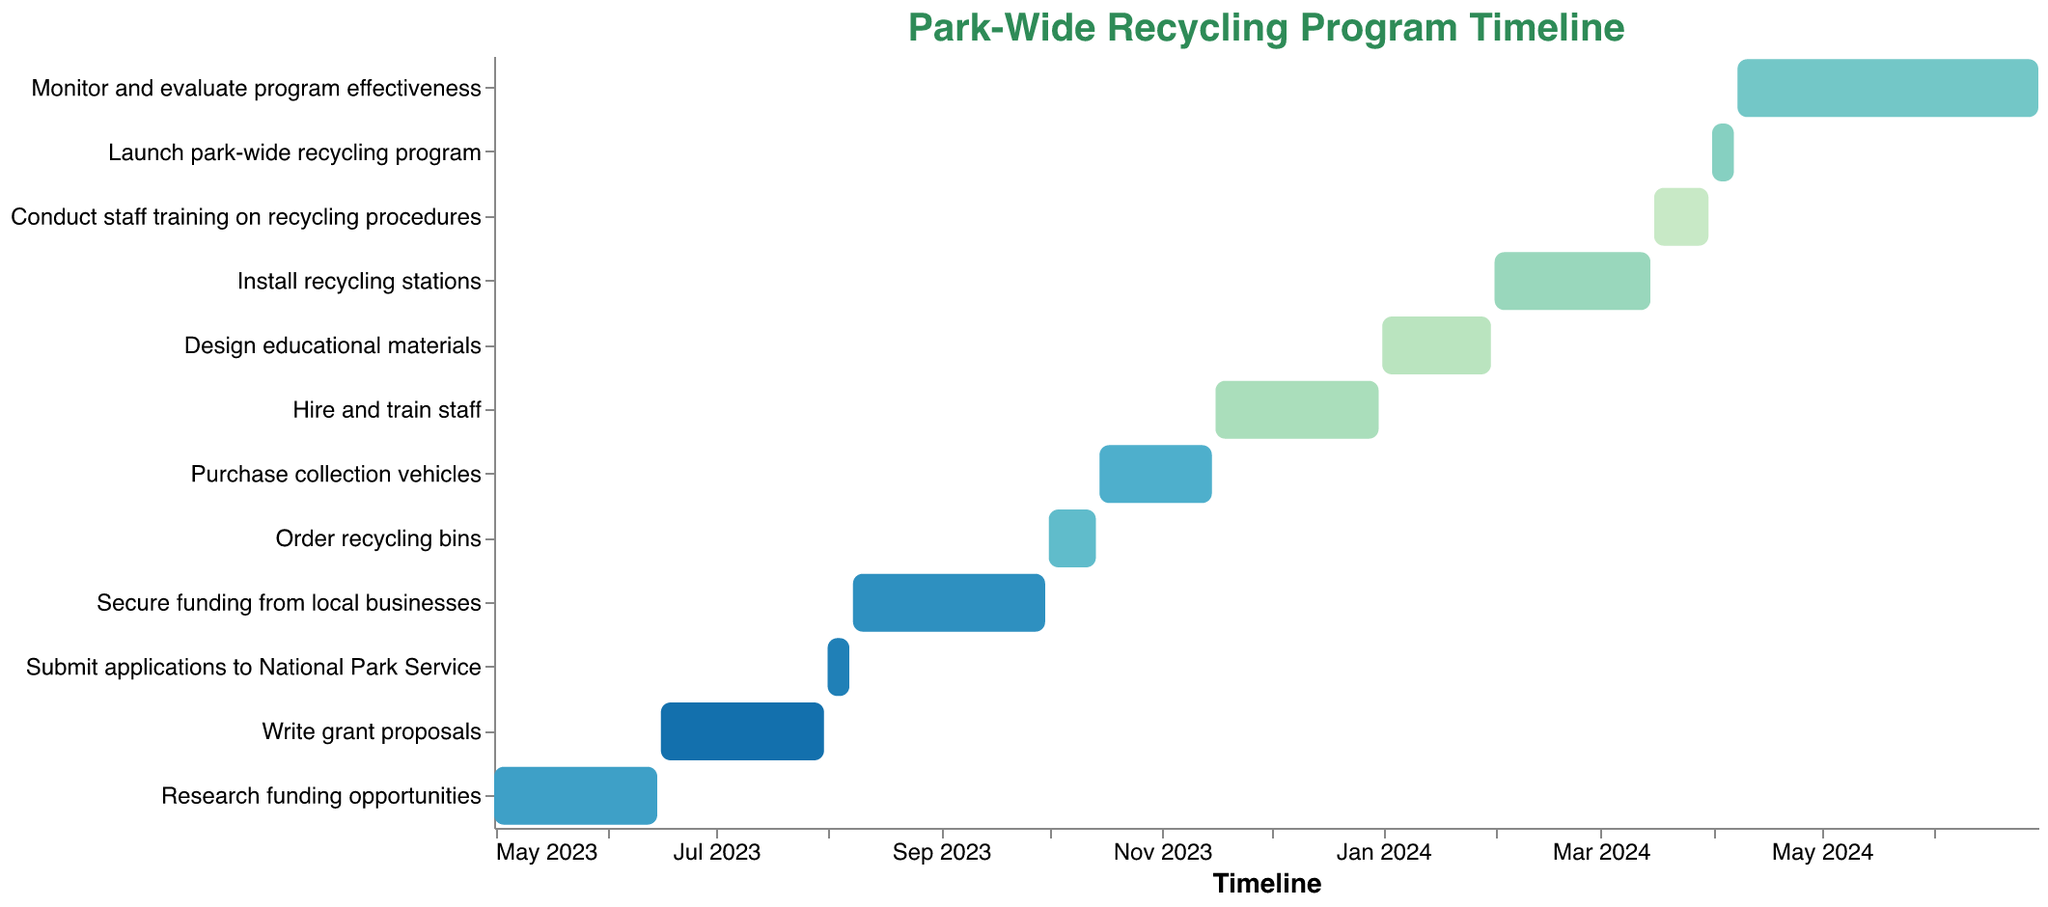What's the title of the chart? The title is displayed at the top of the figure. It reads "Park-Wide Recycling Program Timeline"
Answer: Park-Wide Recycling Program Timeline What is the date range for researching funding opportunities? The date range for a task is indicated by the start date and end date. For "Research funding opportunities," it's from May 1, 2023 to June 15, 2023
Answer: May 1, 2023 to June 15, 2023 How many tasks are there in total in the program timeline? By counting the different tasks listed along the y-axis, we can determine the total number. There are 12 tasks shown
Answer: 12 Which task has the longest duration? To find the longest duration, compare the time spans of each task by looking at their start and end dates. "Monitor and evaluate program effectiveness" runs from April 8, 2024 to June 30, 2024, which is the longest.
Answer: Monitor and evaluate program effectiveness Which two tasks overlap in November 2023? By checking the time spans of all tasks around November 2023, we see that "Purchase collection vehicles" (October 15, 2023 to November 15, 2023) and "Hire and train staff" (November 16, 2023 to December 31, 2023) are adjacent but do not overlap. Only one task is during this period.
Answer: None What is the total duration for hiring and training staff? The total duration is the difference between the start date and end date of a task. "Hire and train staff" runs from November 16, 2023 to December 31, 2023. This period covers 46 days (30 days in December starting from Nov 16 + 16 days in November).
Answer: 46 days What comes after designing educational materials? By looking at the sequential order of tasks on the y-axis, the task that follows "Design educational materials" is "Install recycling stations."
Answer: Install recycling stations Which month has the most tasks starting? By examining the start dates of each task, we can count the tasks starting in each month. October 2023 has the most tasks starting (2 tasks: "Order recycling bins" and "Purchase collection vehicles").
Answer: October 2023 How long does it take to launch the park-wide recycling program? By checking the start and end dates of the "Launch park-wide recycling program" task, which runs from April 1, 2024 to April 7, 2024, we see it takes 7 days.
Answer: 7 days When does the timeline end? The entire timeline ends on the last date of the final task. "Monitor and evaluate program effectiveness" ends on June 30, 2024, which is the last date.
Answer: June 30, 2024 